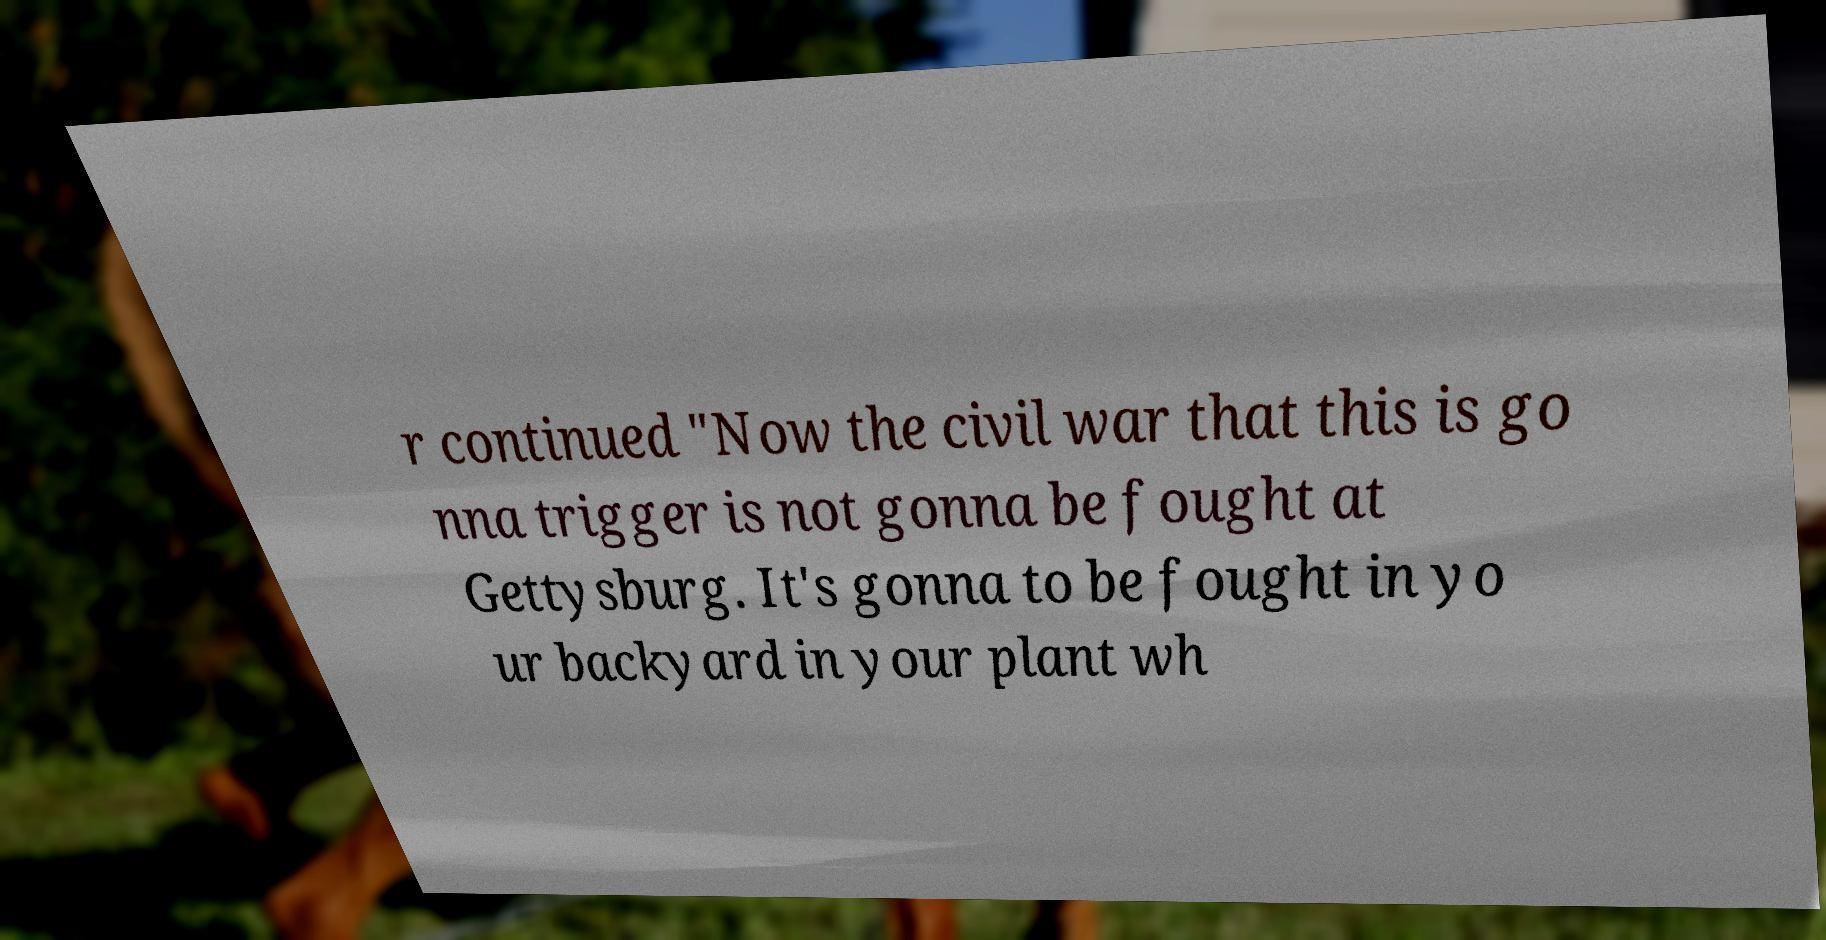I need the written content from this picture converted into text. Can you do that? r continued "Now the civil war that this is go nna trigger is not gonna be fought at Gettysburg. It's gonna to be fought in yo ur backyard in your plant wh 